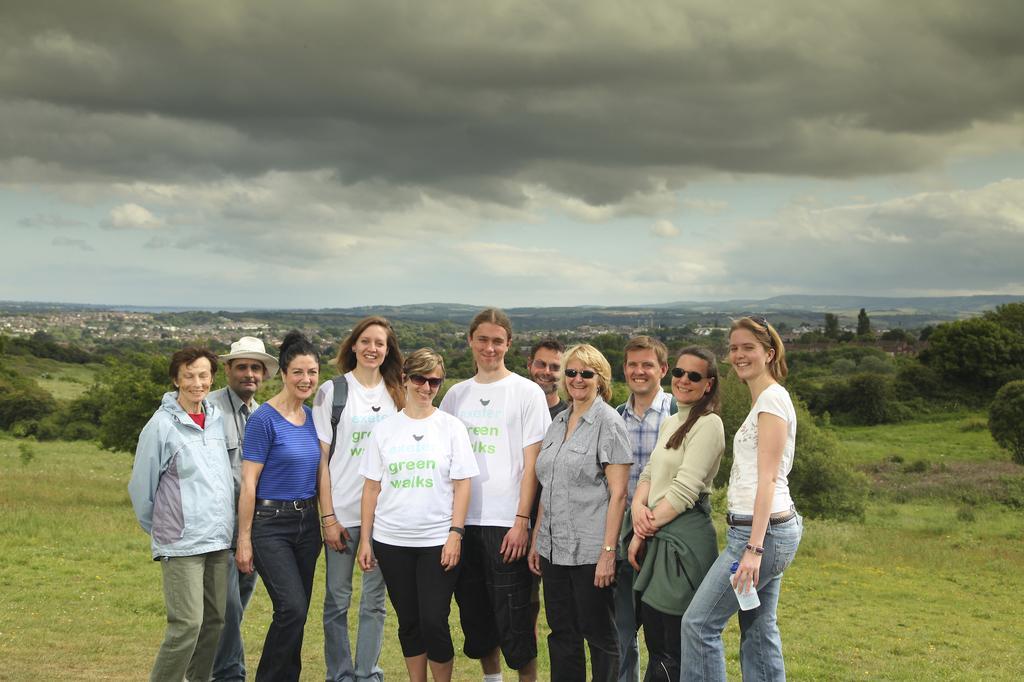Could you give a brief overview of what you see in this image? In this image we can see a group of people standing. A lady is holding some object at the right side of the image. There is a grassy land in the image. There are many trees and plants in the image. There is a blue and cloudy sky in the image. There are few hills in the image. 